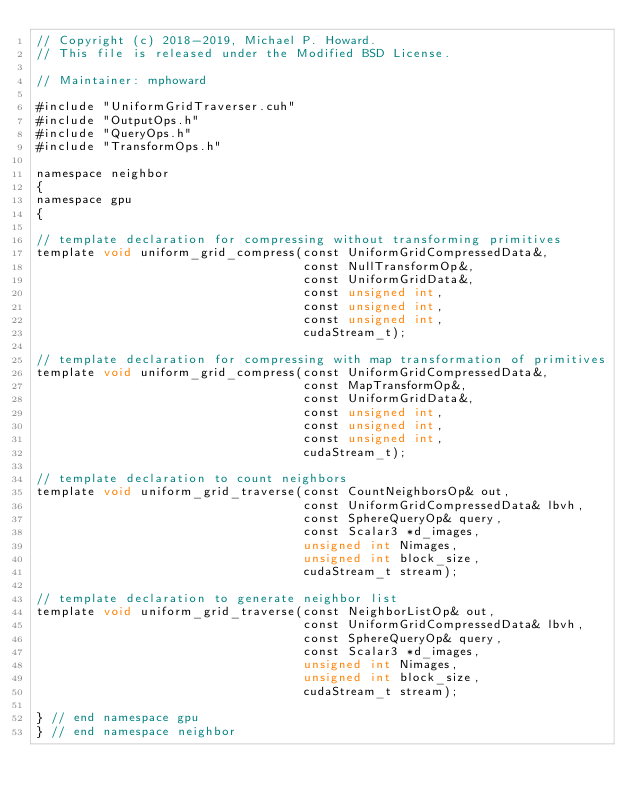Convert code to text. <code><loc_0><loc_0><loc_500><loc_500><_Cuda_>// Copyright (c) 2018-2019, Michael P. Howard.
// This file is released under the Modified BSD License.

// Maintainer: mphoward

#include "UniformGridTraverser.cuh"
#include "OutputOps.h"
#include "QueryOps.h"
#include "TransformOps.h"

namespace neighbor
{
namespace gpu
{

// template declaration for compressing without transforming primitives
template void uniform_grid_compress(const UniformGridCompressedData&,
                                    const NullTransformOp&,
                                    const UniformGridData&,
                                    const unsigned int,
                                    const unsigned int,
                                    const unsigned int,
                                    cudaStream_t);

// template declaration for compressing with map transformation of primitives
template void uniform_grid_compress(const UniformGridCompressedData&,
                                    const MapTransformOp&,
                                    const UniformGridData&,
                                    const unsigned int,
                                    const unsigned int,
                                    const unsigned int,
                                    cudaStream_t);

// template declaration to count neighbors
template void uniform_grid_traverse(const CountNeighborsOp& out,
                                    const UniformGridCompressedData& lbvh,
                                    const SphereQueryOp& query,
                                    const Scalar3 *d_images,
                                    unsigned int Nimages,
                                    unsigned int block_size,
                                    cudaStream_t stream);

// template declaration to generate neighbor list
template void uniform_grid_traverse(const NeighborListOp& out,
                                    const UniformGridCompressedData& lbvh,
                                    const SphereQueryOp& query,
                                    const Scalar3 *d_images,
                                    unsigned int Nimages,
                                    unsigned int block_size,
                                    cudaStream_t stream);

} // end namespace gpu
} // end namespace neighbor
</code> 